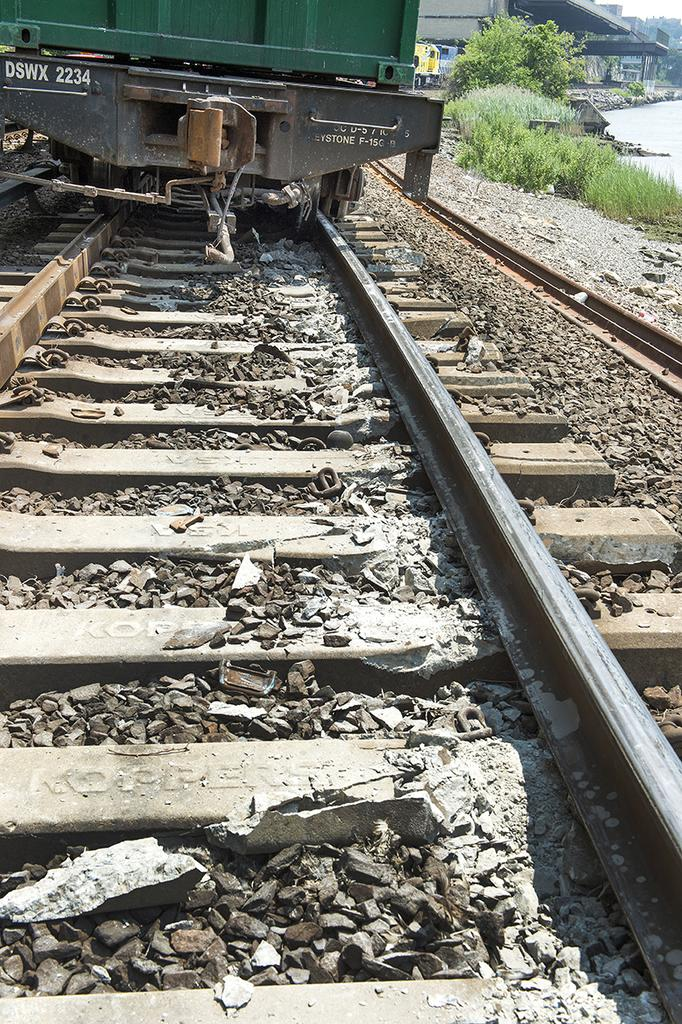What is the main subject of the image? The main subject of the image is a railway track. What is on the railway track? There is a train on the railway track. What can be seen on the right side of the image? There are green color plants on the right side of the image. Where is the scarecrow standing in the image? There is no scarecrow present in the image. How many wings can be seen on the train in the image? Trains do not have wings, so there are no wings visible on the train in the image. 